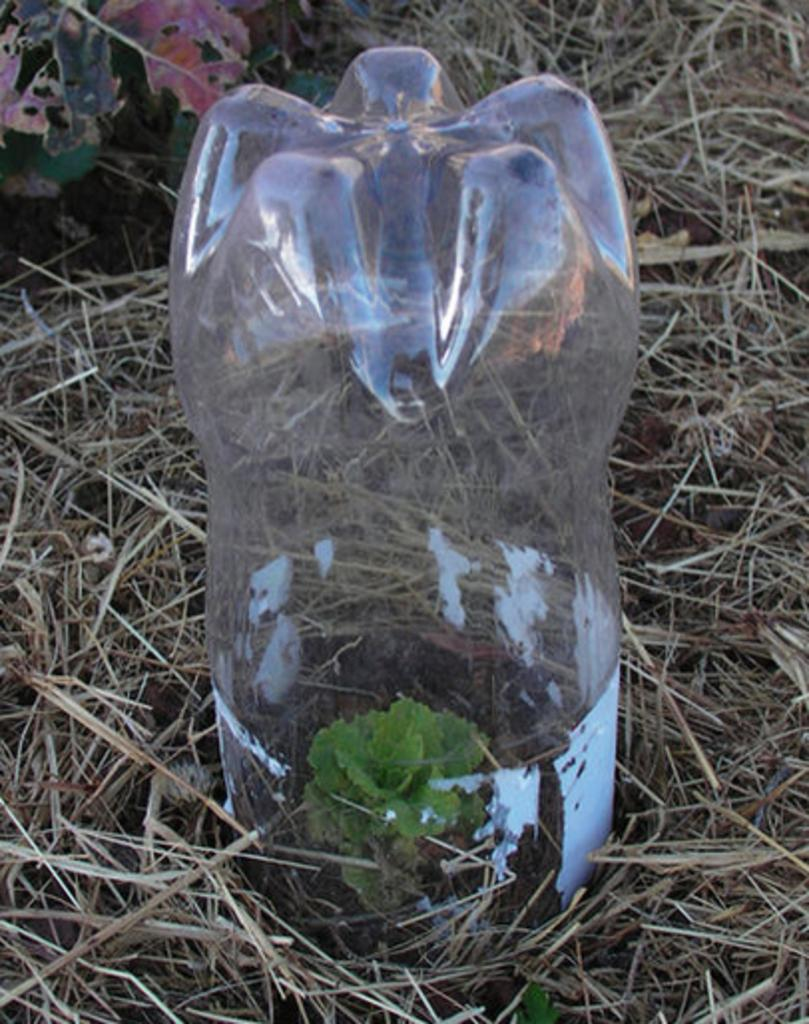What object is present in the image that is commonly used for holding liquids? There is a plastic bottle in the image. What is the plastic bottle doing in the image? The plastic bottle is covering a small plant. What type of vegetation can be seen in the image? There is dried grass in the image. Can you see a cup being held by a hand in the image? There is no cup or hand present in the image. What type of quiver is visible in the image? There is no quiver present in the image. 